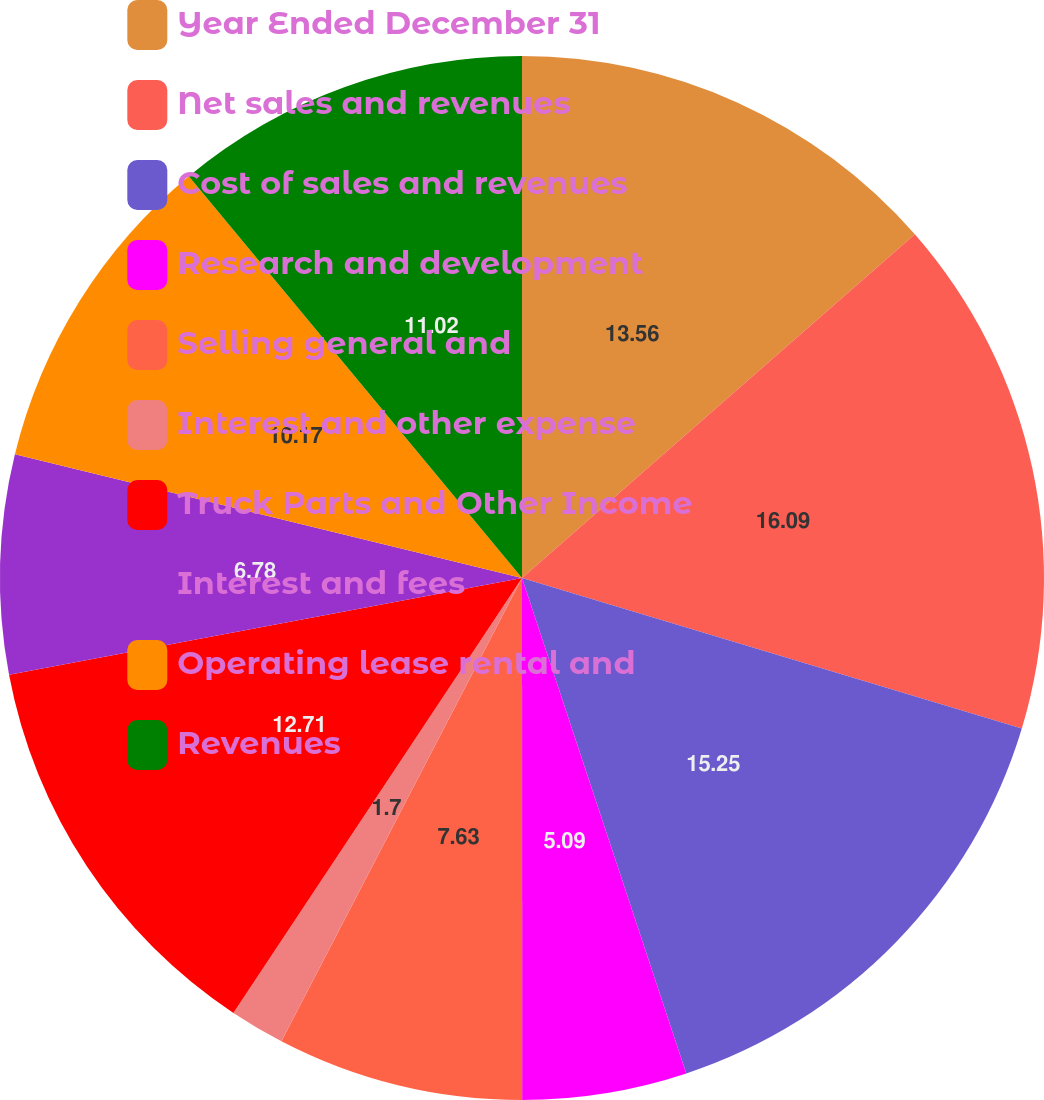Convert chart to OTSL. <chart><loc_0><loc_0><loc_500><loc_500><pie_chart><fcel>Year Ended December 31<fcel>Net sales and revenues<fcel>Cost of sales and revenues<fcel>Research and development<fcel>Selling general and<fcel>Interest and other expense<fcel>Truck Parts and Other Income<fcel>Interest and fees<fcel>Operating lease rental and<fcel>Revenues<nl><fcel>13.56%<fcel>16.1%<fcel>15.25%<fcel>5.09%<fcel>7.63%<fcel>1.7%<fcel>12.71%<fcel>6.78%<fcel>10.17%<fcel>11.02%<nl></chart> 